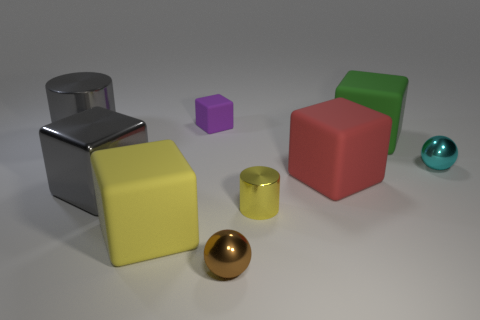There is a red object that is made of the same material as the big green thing; what shape is it? The red object shares its smooth, solid surface with the larger green item, which is indicative of the same material - likely a type of plastic. Both objects possess distinct geometric shapes. The red object in question is a cube, characterized by its equal-length sides and 90-degree angles, making it a perfect example of the three-dimensional embodiment of a quadrilateral. 